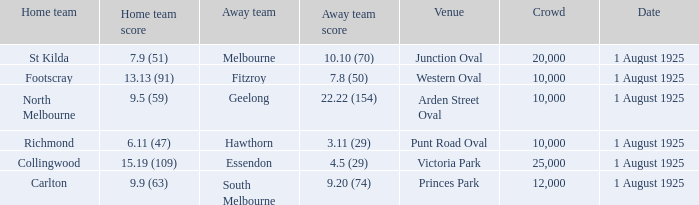What was the away team's score at the match played at The Western Oval? 7.8 (50). 